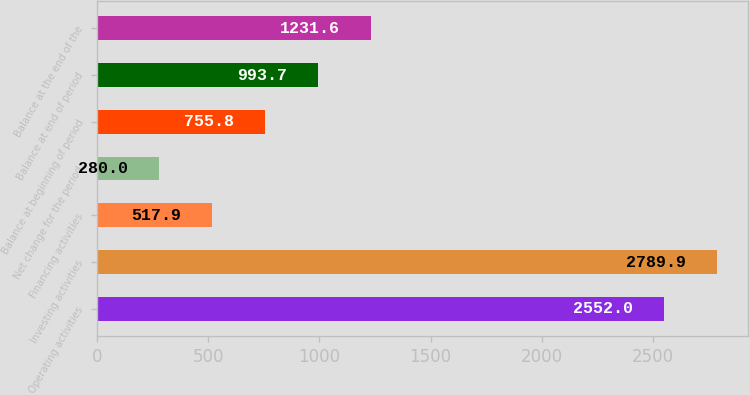<chart> <loc_0><loc_0><loc_500><loc_500><bar_chart><fcel>Operating activities<fcel>Investing activities<fcel>Financing activities<fcel>Net change for the period<fcel>Balance at beginning of period<fcel>Balance at end of period<fcel>Balance at the end of the<nl><fcel>2552<fcel>2789.9<fcel>517.9<fcel>280<fcel>755.8<fcel>993.7<fcel>1231.6<nl></chart> 